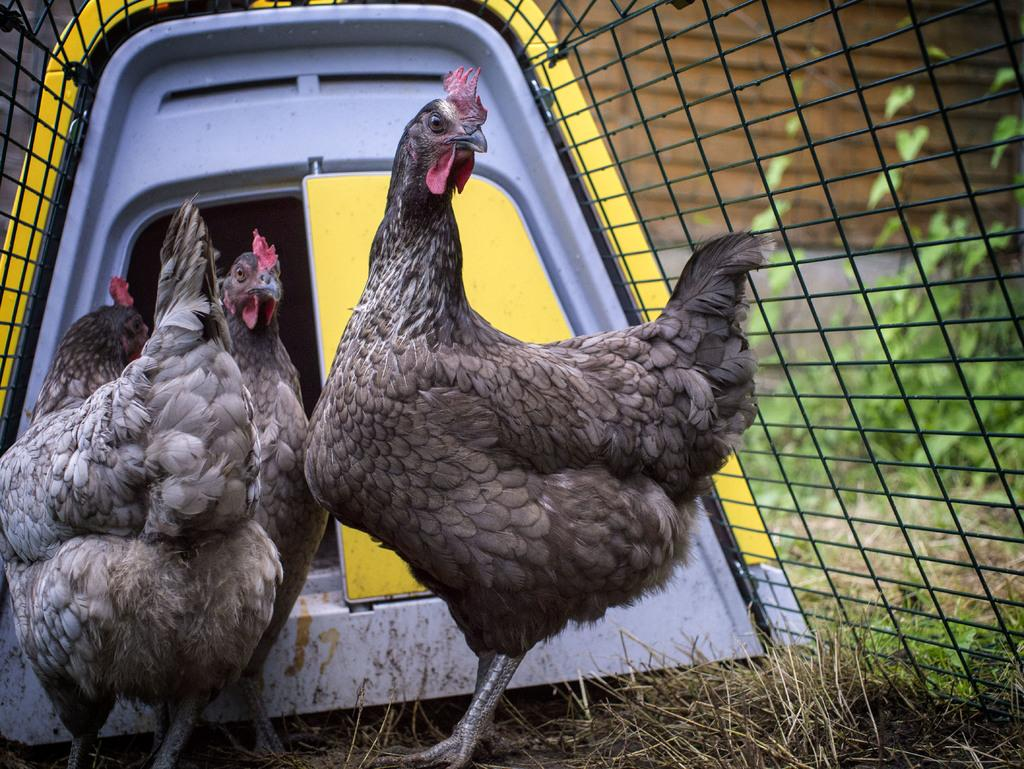What animals are inside the cage in the image? There are hens inside a cage in the image. What type of surface is visible at the bottom of the image? There is grass on the surface at the bottom of the image. What can be seen on the right side of the image? There are plants on the right side of the image. What is the price of the flag in the image? There is no flag present in the image, so it is not possible to determine its price. 